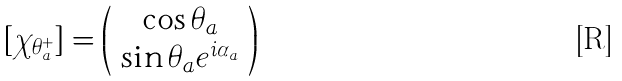Convert formula to latex. <formula><loc_0><loc_0><loc_500><loc_500>[ \chi _ { \theta _ { a } ^ { + } } ] = \left ( \begin{array} { c } \cos \theta _ { a } \\ \sin \theta _ { a } e ^ { i \alpha _ { a } } \end{array} \right )</formula> 